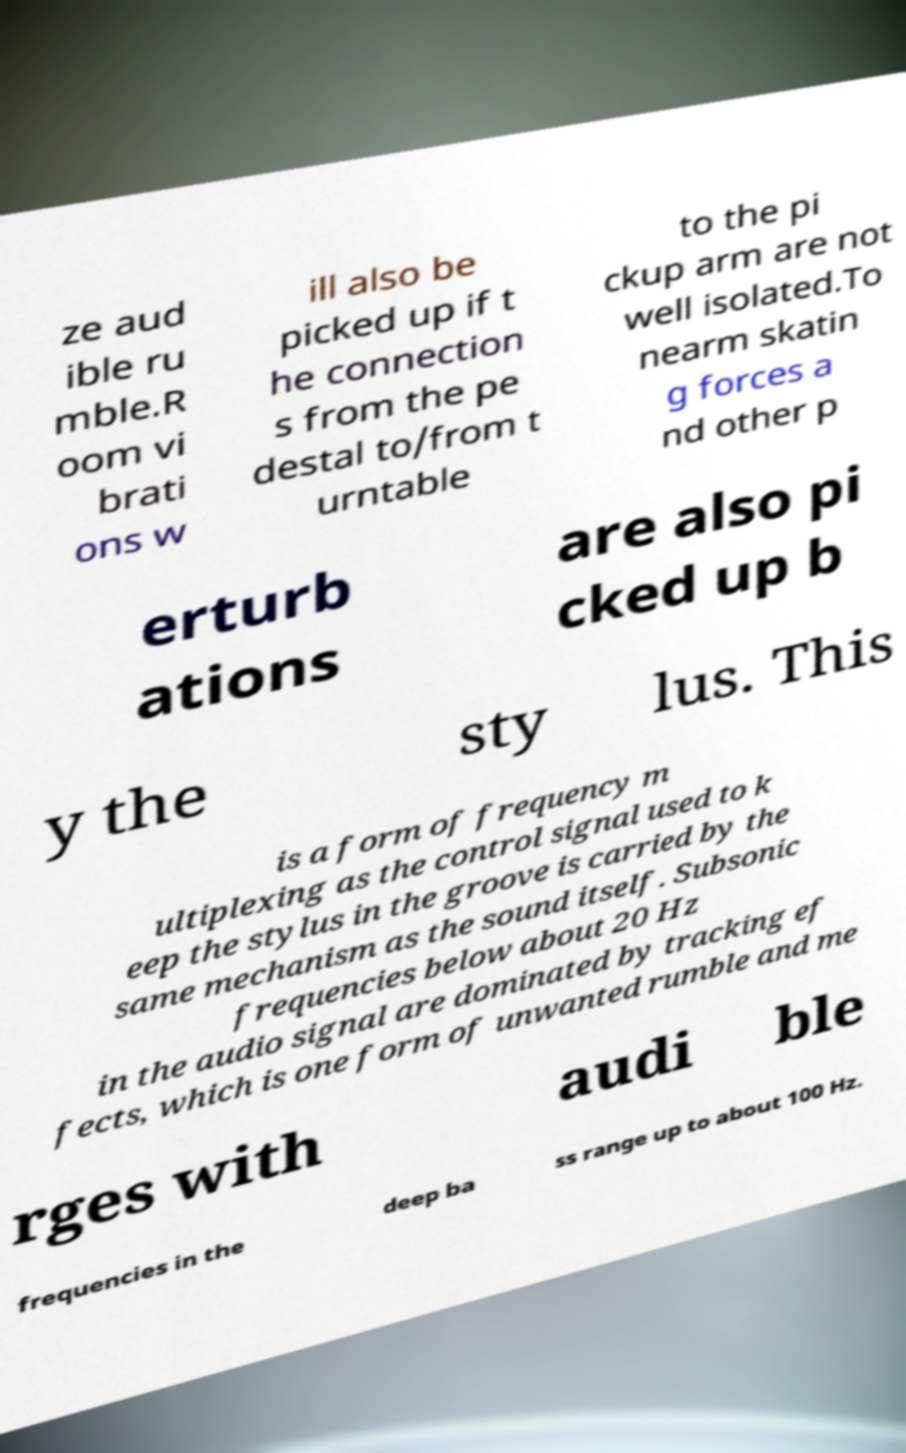Can you read and provide the text displayed in the image?This photo seems to have some interesting text. Can you extract and type it out for me? ze aud ible ru mble.R oom vi brati ons w ill also be picked up if t he connection s from the pe destal to/from t urntable to the pi ckup arm are not well isolated.To nearm skatin g forces a nd other p erturb ations are also pi cked up b y the sty lus. This is a form of frequency m ultiplexing as the control signal used to k eep the stylus in the groove is carried by the same mechanism as the sound itself. Subsonic frequencies below about 20 Hz in the audio signal are dominated by tracking ef fects, which is one form of unwanted rumble and me rges with audi ble frequencies in the deep ba ss range up to about 100 Hz. 